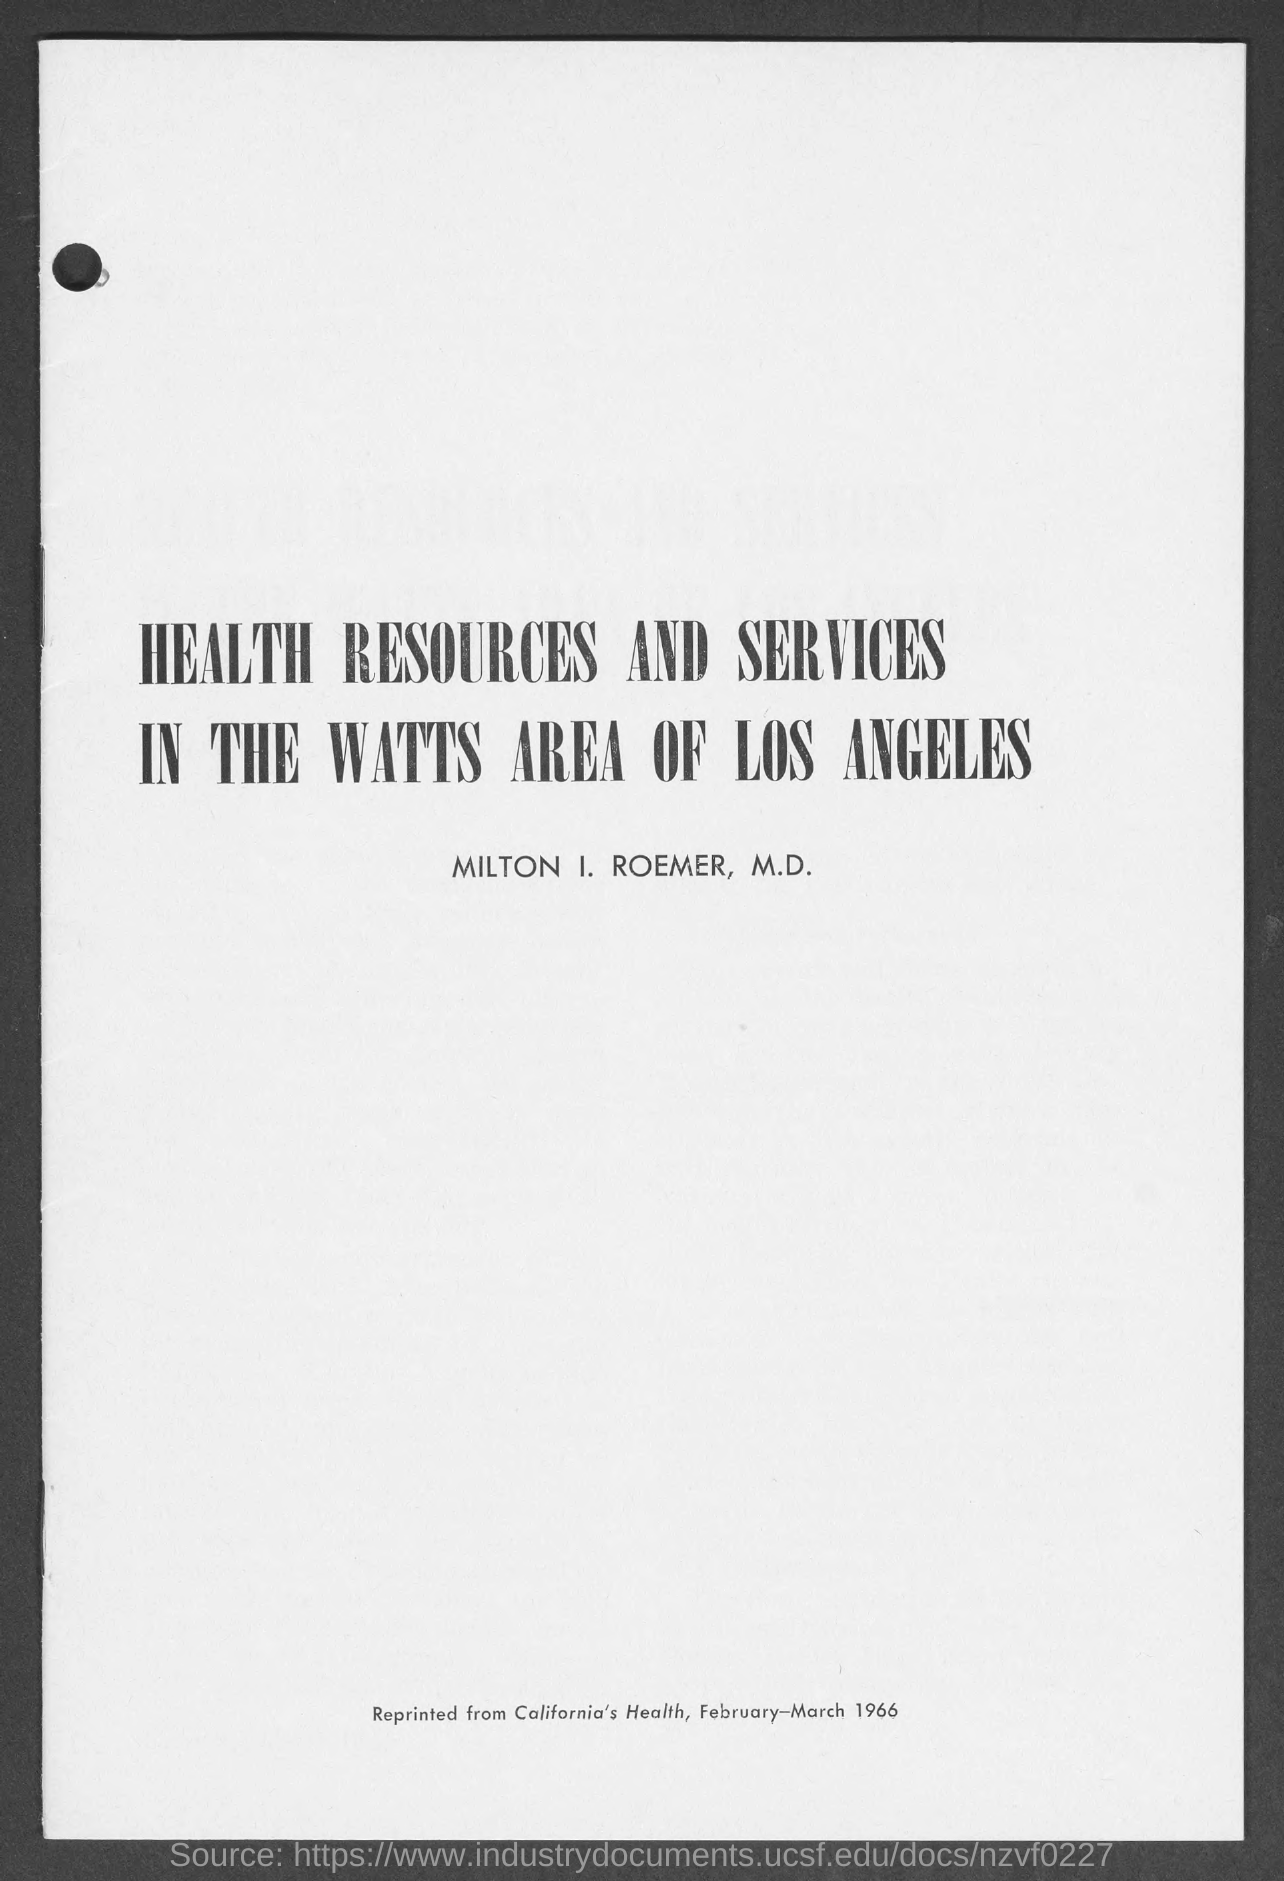What is the title of the document?
Your answer should be compact. HEALTH RESOURCES AND SERVICES IN THE WATTS AREA OF LOS ANGELES. What is the date mentioned in the document?
Your answer should be very brief. February-March 1966. What is the name of the person mentioned in the document?
Your response must be concise. MILTON I. ROEMER. 